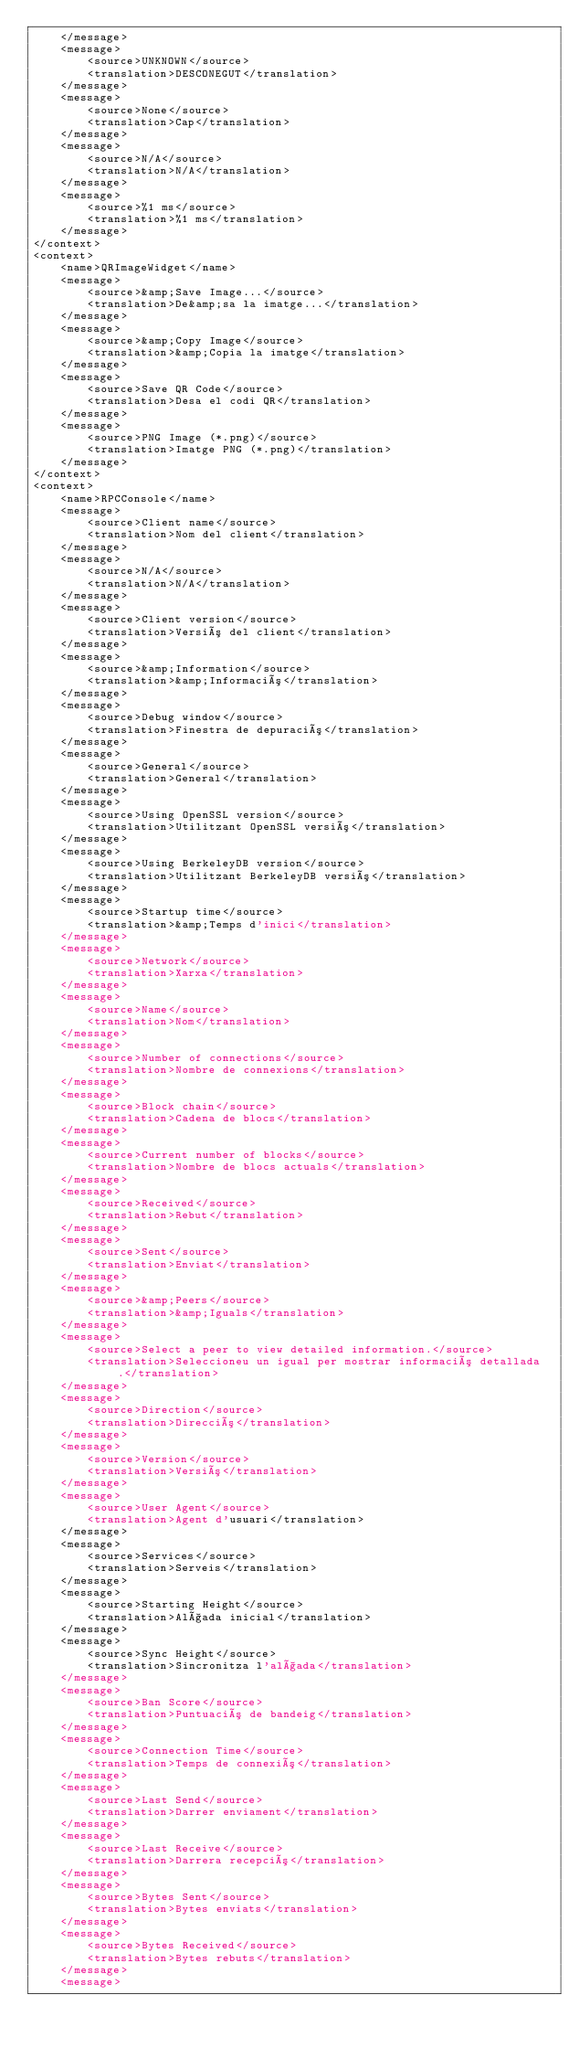Convert code to text. <code><loc_0><loc_0><loc_500><loc_500><_TypeScript_>    </message>
    <message>
        <source>UNKNOWN</source>
        <translation>DESCONEGUT</translation>
    </message>
    <message>
        <source>None</source>
        <translation>Cap</translation>
    </message>
    <message>
        <source>N/A</source>
        <translation>N/A</translation>
    </message>
    <message>
        <source>%1 ms</source>
        <translation>%1 ms</translation>
    </message>
</context>
<context>
    <name>QRImageWidget</name>
    <message>
        <source>&amp;Save Image...</source>
        <translation>De&amp;sa la imatge...</translation>
    </message>
    <message>
        <source>&amp;Copy Image</source>
        <translation>&amp;Copia la imatge</translation>
    </message>
    <message>
        <source>Save QR Code</source>
        <translation>Desa el codi QR</translation>
    </message>
    <message>
        <source>PNG Image (*.png)</source>
        <translation>Imatge PNG (*.png)</translation>
    </message>
</context>
<context>
    <name>RPCConsole</name>
    <message>
        <source>Client name</source>
        <translation>Nom del client</translation>
    </message>
    <message>
        <source>N/A</source>
        <translation>N/A</translation>
    </message>
    <message>
        <source>Client version</source>
        <translation>Versió del client</translation>
    </message>
    <message>
        <source>&amp;Information</source>
        <translation>&amp;Informació</translation>
    </message>
    <message>
        <source>Debug window</source>
        <translation>Finestra de depuració</translation>
    </message>
    <message>
        <source>General</source>
        <translation>General</translation>
    </message>
    <message>
        <source>Using OpenSSL version</source>
        <translation>Utilitzant OpenSSL versió</translation>
    </message>
    <message>
        <source>Using BerkeleyDB version</source>
        <translation>Utilitzant BerkeleyDB versió</translation>
    </message>
    <message>
        <source>Startup time</source>
        <translation>&amp;Temps d'inici</translation>
    </message>
    <message>
        <source>Network</source>
        <translation>Xarxa</translation>
    </message>
    <message>
        <source>Name</source>
        <translation>Nom</translation>
    </message>
    <message>
        <source>Number of connections</source>
        <translation>Nombre de connexions</translation>
    </message>
    <message>
        <source>Block chain</source>
        <translation>Cadena de blocs</translation>
    </message>
    <message>
        <source>Current number of blocks</source>
        <translation>Nombre de blocs actuals</translation>
    </message>
    <message>
        <source>Received</source>
        <translation>Rebut</translation>
    </message>
    <message>
        <source>Sent</source>
        <translation>Enviat</translation>
    </message>
    <message>
        <source>&amp;Peers</source>
        <translation>&amp;Iguals</translation>
    </message>
    <message>
        <source>Select a peer to view detailed information.</source>
        <translation>Seleccioneu un igual per mostrar informació detallada.</translation>
    </message>
    <message>
        <source>Direction</source>
        <translation>Direcció</translation>
    </message>
    <message>
        <source>Version</source>
        <translation>Versió</translation>
    </message>
    <message>
        <source>User Agent</source>
        <translation>Agent d'usuari</translation>
    </message>
    <message>
        <source>Services</source>
        <translation>Serveis</translation>
    </message>
    <message>
        <source>Starting Height</source>
        <translation>Alçada inicial</translation>
    </message>
    <message>
        <source>Sync Height</source>
        <translation>Sincronitza l'alçada</translation>
    </message>
    <message>
        <source>Ban Score</source>
        <translation>Puntuació de bandeig</translation>
    </message>
    <message>
        <source>Connection Time</source>
        <translation>Temps de connexió</translation>
    </message>
    <message>
        <source>Last Send</source>
        <translation>Darrer enviament</translation>
    </message>
    <message>
        <source>Last Receive</source>
        <translation>Darrera recepció</translation>
    </message>
    <message>
        <source>Bytes Sent</source>
        <translation>Bytes enviats</translation>
    </message>
    <message>
        <source>Bytes Received</source>
        <translation>Bytes rebuts</translation>
    </message>
    <message></code> 